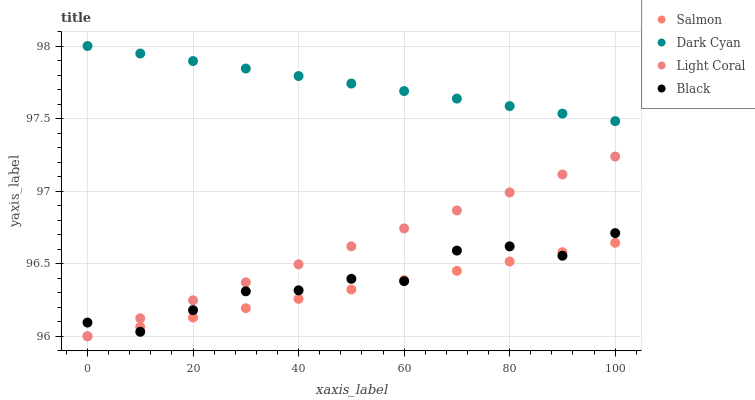Does Salmon have the minimum area under the curve?
Answer yes or no. Yes. Does Dark Cyan have the maximum area under the curve?
Answer yes or no. Yes. Does Light Coral have the minimum area under the curve?
Answer yes or no. No. Does Light Coral have the maximum area under the curve?
Answer yes or no. No. Is Salmon the smoothest?
Answer yes or no. Yes. Is Black the roughest?
Answer yes or no. Yes. Is Light Coral the smoothest?
Answer yes or no. No. Is Light Coral the roughest?
Answer yes or no. No. Does Light Coral have the lowest value?
Answer yes or no. Yes. Does Black have the lowest value?
Answer yes or no. No. Does Dark Cyan have the highest value?
Answer yes or no. Yes. Does Light Coral have the highest value?
Answer yes or no. No. Is Salmon less than Dark Cyan?
Answer yes or no. Yes. Is Dark Cyan greater than Salmon?
Answer yes or no. Yes. Does Salmon intersect Light Coral?
Answer yes or no. Yes. Is Salmon less than Light Coral?
Answer yes or no. No. Is Salmon greater than Light Coral?
Answer yes or no. No. Does Salmon intersect Dark Cyan?
Answer yes or no. No. 